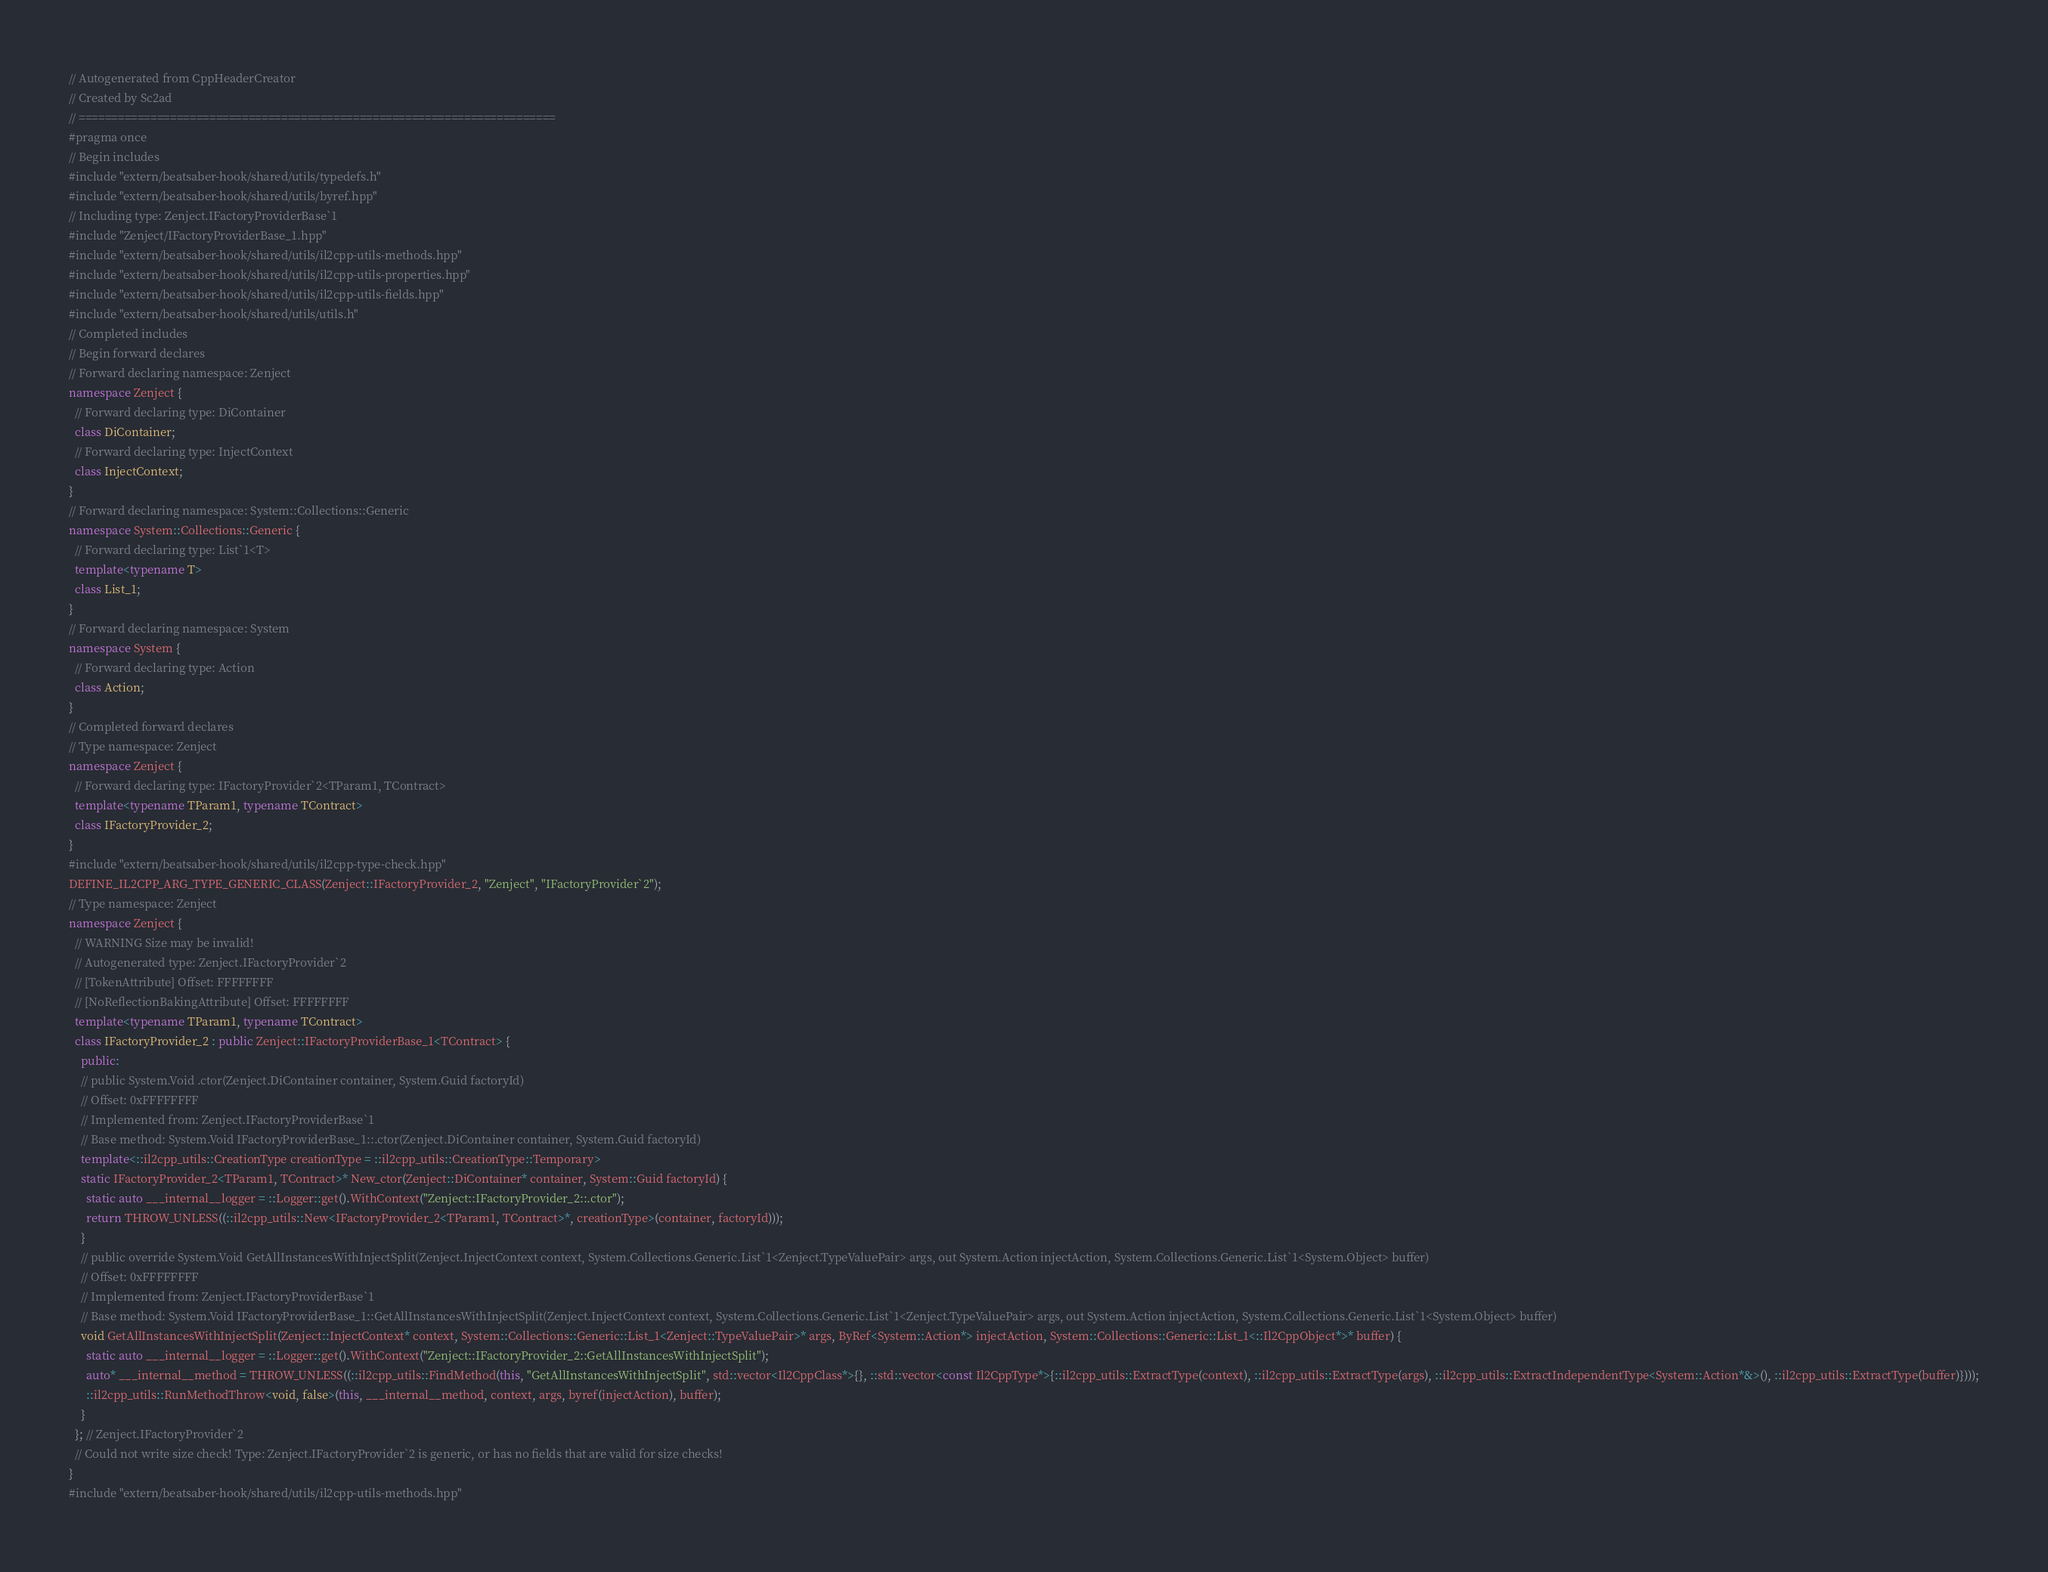<code> <loc_0><loc_0><loc_500><loc_500><_C++_>// Autogenerated from CppHeaderCreator
// Created by Sc2ad
// =========================================================================
#pragma once
// Begin includes
#include "extern/beatsaber-hook/shared/utils/typedefs.h"
#include "extern/beatsaber-hook/shared/utils/byref.hpp"
// Including type: Zenject.IFactoryProviderBase`1
#include "Zenject/IFactoryProviderBase_1.hpp"
#include "extern/beatsaber-hook/shared/utils/il2cpp-utils-methods.hpp"
#include "extern/beatsaber-hook/shared/utils/il2cpp-utils-properties.hpp"
#include "extern/beatsaber-hook/shared/utils/il2cpp-utils-fields.hpp"
#include "extern/beatsaber-hook/shared/utils/utils.h"
// Completed includes
// Begin forward declares
// Forward declaring namespace: Zenject
namespace Zenject {
  // Forward declaring type: DiContainer
  class DiContainer;
  // Forward declaring type: InjectContext
  class InjectContext;
}
// Forward declaring namespace: System::Collections::Generic
namespace System::Collections::Generic {
  // Forward declaring type: List`1<T>
  template<typename T>
  class List_1;
}
// Forward declaring namespace: System
namespace System {
  // Forward declaring type: Action
  class Action;
}
// Completed forward declares
// Type namespace: Zenject
namespace Zenject {
  // Forward declaring type: IFactoryProvider`2<TParam1, TContract>
  template<typename TParam1, typename TContract>
  class IFactoryProvider_2;
}
#include "extern/beatsaber-hook/shared/utils/il2cpp-type-check.hpp"
DEFINE_IL2CPP_ARG_TYPE_GENERIC_CLASS(Zenject::IFactoryProvider_2, "Zenject", "IFactoryProvider`2");
// Type namespace: Zenject
namespace Zenject {
  // WARNING Size may be invalid!
  // Autogenerated type: Zenject.IFactoryProvider`2
  // [TokenAttribute] Offset: FFFFFFFF
  // [NoReflectionBakingAttribute] Offset: FFFFFFFF
  template<typename TParam1, typename TContract>
  class IFactoryProvider_2 : public Zenject::IFactoryProviderBase_1<TContract> {
    public:
    // public System.Void .ctor(Zenject.DiContainer container, System.Guid factoryId)
    // Offset: 0xFFFFFFFF
    // Implemented from: Zenject.IFactoryProviderBase`1
    // Base method: System.Void IFactoryProviderBase_1::.ctor(Zenject.DiContainer container, System.Guid factoryId)
    template<::il2cpp_utils::CreationType creationType = ::il2cpp_utils::CreationType::Temporary>
    static IFactoryProvider_2<TParam1, TContract>* New_ctor(Zenject::DiContainer* container, System::Guid factoryId) {
      static auto ___internal__logger = ::Logger::get().WithContext("Zenject::IFactoryProvider_2::.ctor");
      return THROW_UNLESS((::il2cpp_utils::New<IFactoryProvider_2<TParam1, TContract>*, creationType>(container, factoryId)));
    }
    // public override System.Void GetAllInstancesWithInjectSplit(Zenject.InjectContext context, System.Collections.Generic.List`1<Zenject.TypeValuePair> args, out System.Action injectAction, System.Collections.Generic.List`1<System.Object> buffer)
    // Offset: 0xFFFFFFFF
    // Implemented from: Zenject.IFactoryProviderBase`1
    // Base method: System.Void IFactoryProviderBase_1::GetAllInstancesWithInjectSplit(Zenject.InjectContext context, System.Collections.Generic.List`1<Zenject.TypeValuePair> args, out System.Action injectAction, System.Collections.Generic.List`1<System.Object> buffer)
    void GetAllInstancesWithInjectSplit(Zenject::InjectContext* context, System::Collections::Generic::List_1<Zenject::TypeValuePair>* args, ByRef<System::Action*> injectAction, System::Collections::Generic::List_1<::Il2CppObject*>* buffer) {
      static auto ___internal__logger = ::Logger::get().WithContext("Zenject::IFactoryProvider_2::GetAllInstancesWithInjectSplit");
      auto* ___internal__method = THROW_UNLESS((::il2cpp_utils::FindMethod(this, "GetAllInstancesWithInjectSplit", std::vector<Il2CppClass*>{}, ::std::vector<const Il2CppType*>{::il2cpp_utils::ExtractType(context), ::il2cpp_utils::ExtractType(args), ::il2cpp_utils::ExtractIndependentType<System::Action*&>(), ::il2cpp_utils::ExtractType(buffer)})));
      ::il2cpp_utils::RunMethodThrow<void, false>(this, ___internal__method, context, args, byref(injectAction), buffer);
    }
  }; // Zenject.IFactoryProvider`2
  // Could not write size check! Type: Zenject.IFactoryProvider`2 is generic, or has no fields that are valid for size checks!
}
#include "extern/beatsaber-hook/shared/utils/il2cpp-utils-methods.hpp"
</code> 